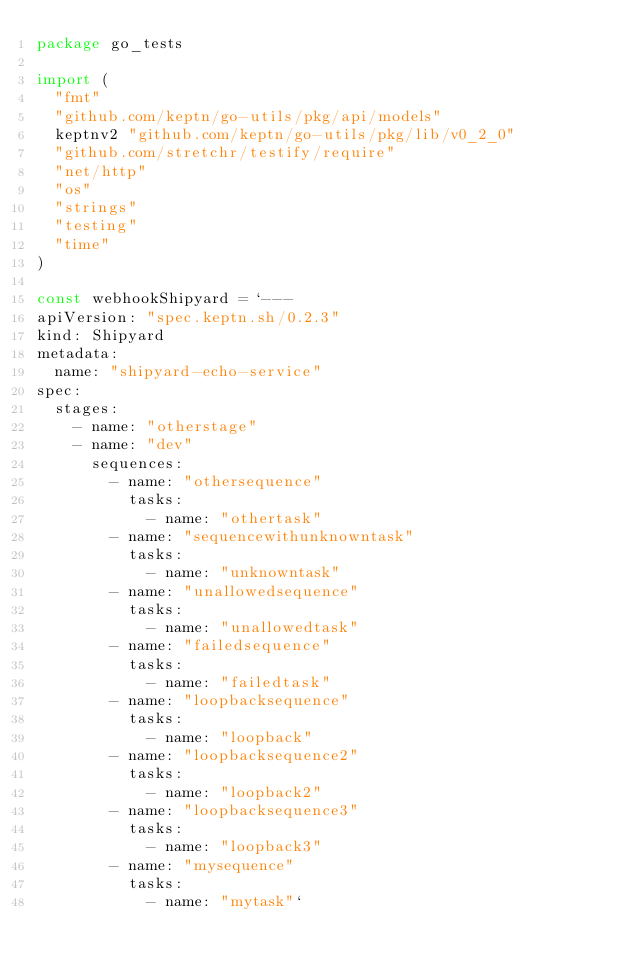<code> <loc_0><loc_0><loc_500><loc_500><_Go_>package go_tests

import (
	"fmt"
	"github.com/keptn/go-utils/pkg/api/models"
	keptnv2 "github.com/keptn/go-utils/pkg/lib/v0_2_0"
	"github.com/stretchr/testify/require"
	"net/http"
	"os"
	"strings"
	"testing"
	"time"
)

const webhookShipyard = `--- 
apiVersion: "spec.keptn.sh/0.2.3"
kind: Shipyard
metadata:
  name: "shipyard-echo-service"
spec:
  stages:
    - name: "otherstage"
    - name: "dev"
      sequences:
        - name: "othersequence"
          tasks:
            - name: "othertask"
        - name: "sequencewithunknowntask"
          tasks:
            - name: "unknowntask"
        - name: "unallowedsequence"
          tasks:
            - name: "unallowedtask"
        - name: "failedsequence"
          tasks:
            - name: "failedtask"
        - name: "loopbacksequence"
          tasks:
            - name: "loopback"
        - name: "loopbacksequence2"
          tasks:
            - name: "loopback2"
        - name: "loopbacksequence3"
          tasks:
            - name: "loopback3"
        - name: "mysequence"
          tasks:
            - name: "mytask"`
</code> 